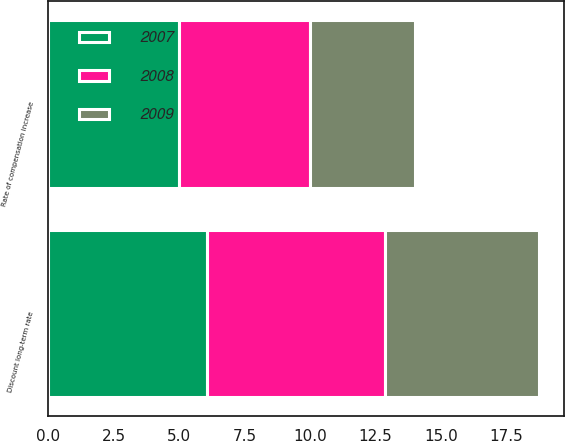Convert chart to OTSL. <chart><loc_0><loc_0><loc_500><loc_500><stacked_bar_chart><ecel><fcel>Discount long-term rate<fcel>Rate of compensation increase<nl><fcel>2007<fcel>6.05<fcel>5<nl><fcel>2008<fcel>6.8<fcel>5<nl><fcel>2009<fcel>5.9<fcel>4<nl></chart> 